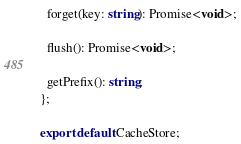Convert code to text. <code><loc_0><loc_0><loc_500><loc_500><_TypeScript_>
  forget(key: string): Promise<void>;

  flush(): Promise<void>;

  getPrefix(): string;
};

export default CacheStore;
</code> 